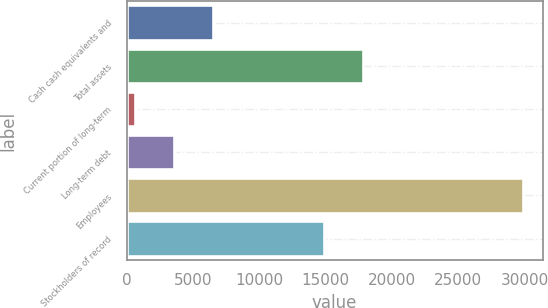Convert chart. <chart><loc_0><loc_0><loc_500><loc_500><bar_chart><fcel>Cash cash equivalents and<fcel>Total assets<fcel>Current portion of long-term<fcel>Long-term debt<fcel>Employees<fcel>Stockholders of record<nl><fcel>6477.8<fcel>17833.4<fcel>631<fcel>3554.4<fcel>29865<fcel>14910<nl></chart> 